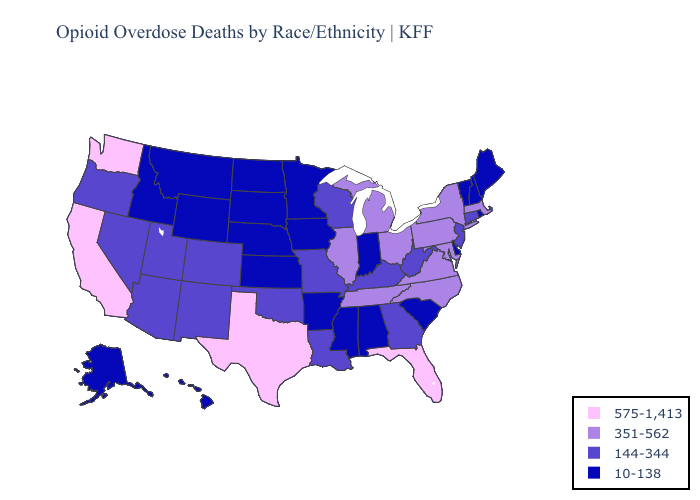What is the value of Alabama?
Write a very short answer. 10-138. Name the states that have a value in the range 575-1,413?
Short answer required. California, Florida, Texas, Washington. Name the states that have a value in the range 351-562?
Short answer required. Illinois, Maryland, Massachusetts, Michigan, New York, North Carolina, Ohio, Pennsylvania, Tennessee, Virginia. What is the highest value in the USA?
Keep it brief. 575-1,413. What is the lowest value in the USA?
Write a very short answer. 10-138. Is the legend a continuous bar?
Be succinct. No. What is the value of Oregon?
Give a very brief answer. 144-344. Among the states that border Alabama , does Tennessee have the lowest value?
Short answer required. No. What is the lowest value in the Northeast?
Short answer required. 10-138. Does Maine have the highest value in the USA?
Write a very short answer. No. What is the value of Connecticut?
Quick response, please. 144-344. Which states have the highest value in the USA?
Be succinct. California, Florida, Texas, Washington. What is the highest value in the USA?
Give a very brief answer. 575-1,413. What is the value of Vermont?
Concise answer only. 10-138. What is the value of Georgia?
Answer briefly. 144-344. 